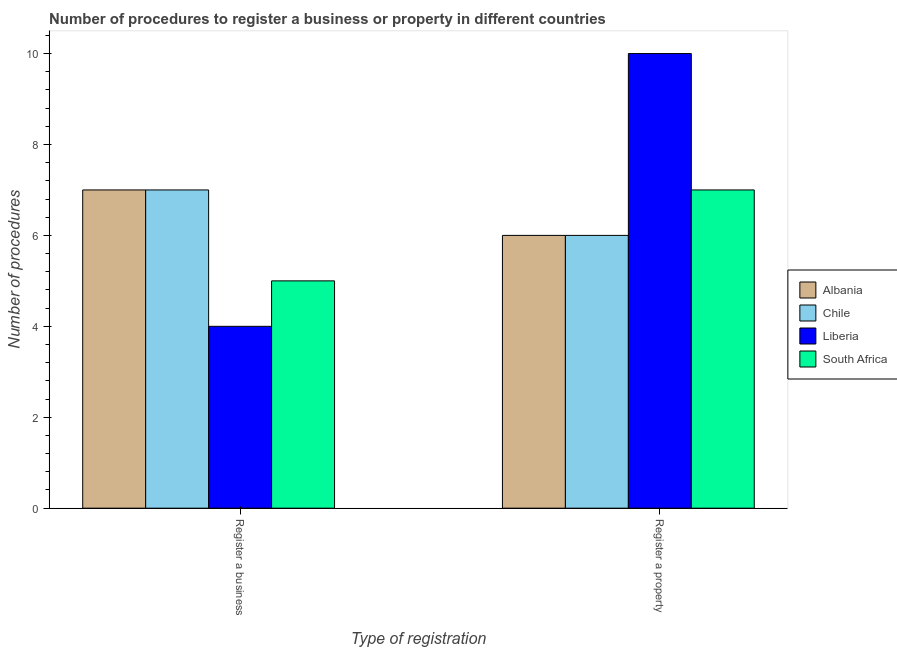How many groups of bars are there?
Provide a succinct answer. 2. How many bars are there on the 1st tick from the left?
Provide a succinct answer. 4. How many bars are there on the 2nd tick from the right?
Your answer should be compact. 4. What is the label of the 1st group of bars from the left?
Give a very brief answer. Register a business. What is the number of procedures to register a business in Chile?
Your response must be concise. 7. Across all countries, what is the maximum number of procedures to register a property?
Offer a terse response. 10. Across all countries, what is the minimum number of procedures to register a business?
Ensure brevity in your answer.  4. In which country was the number of procedures to register a property maximum?
Your answer should be compact. Liberia. In which country was the number of procedures to register a business minimum?
Give a very brief answer. Liberia. What is the total number of procedures to register a property in the graph?
Ensure brevity in your answer.  29. What is the difference between the number of procedures to register a property in Chile and that in Albania?
Ensure brevity in your answer.  0. What is the difference between the number of procedures to register a property in Liberia and the number of procedures to register a business in Chile?
Ensure brevity in your answer.  3. What is the average number of procedures to register a property per country?
Make the answer very short. 7.25. What is the difference between the number of procedures to register a business and number of procedures to register a property in South Africa?
Your answer should be very brief. -2. In how many countries, is the number of procedures to register a property greater than 8.4 ?
Your answer should be very brief. 1. What is the ratio of the number of procedures to register a property in Chile to that in South Africa?
Provide a succinct answer. 0.86. What does the 1st bar from the left in Register a property represents?
Ensure brevity in your answer.  Albania. What does the 4th bar from the right in Register a business represents?
Keep it short and to the point. Albania. How many countries are there in the graph?
Offer a terse response. 4. Are the values on the major ticks of Y-axis written in scientific E-notation?
Offer a terse response. No. Does the graph contain grids?
Your answer should be compact. No. Where does the legend appear in the graph?
Offer a very short reply. Center right. What is the title of the graph?
Provide a short and direct response. Number of procedures to register a business or property in different countries. Does "Senegal" appear as one of the legend labels in the graph?
Offer a terse response. No. What is the label or title of the X-axis?
Your response must be concise. Type of registration. What is the label or title of the Y-axis?
Provide a succinct answer. Number of procedures. What is the Number of procedures of Liberia in Register a business?
Offer a very short reply. 4. What is the Number of procedures in South Africa in Register a business?
Make the answer very short. 5. What is the Number of procedures in Chile in Register a property?
Your response must be concise. 6. What is the Number of procedures in Liberia in Register a property?
Make the answer very short. 10. Across all Type of registration, what is the maximum Number of procedures of Chile?
Offer a terse response. 7. Across all Type of registration, what is the maximum Number of procedures in South Africa?
Provide a short and direct response. 7. Across all Type of registration, what is the minimum Number of procedures of Liberia?
Offer a terse response. 4. Across all Type of registration, what is the minimum Number of procedures in South Africa?
Offer a terse response. 5. What is the total Number of procedures in Albania in the graph?
Your answer should be very brief. 13. What is the total Number of procedures in Liberia in the graph?
Keep it short and to the point. 14. What is the difference between the Number of procedures in South Africa in Register a business and that in Register a property?
Keep it short and to the point. -2. What is the difference between the Number of procedures of Albania in Register a business and the Number of procedures of Chile in Register a property?
Your answer should be compact. 1. What is the difference between the Number of procedures of Liberia in Register a business and the Number of procedures of South Africa in Register a property?
Your answer should be compact. -3. What is the difference between the Number of procedures of Albania and Number of procedures of Liberia in Register a business?
Your answer should be compact. 3. What is the difference between the Number of procedures in Albania and Number of procedures in South Africa in Register a business?
Offer a very short reply. 2. What is the difference between the Number of procedures of Chile and Number of procedures of Liberia in Register a business?
Provide a succinct answer. 3. What is the difference between the Number of procedures in Liberia and Number of procedures in South Africa in Register a business?
Provide a succinct answer. -1. What is the difference between the Number of procedures of Albania and Number of procedures of South Africa in Register a property?
Make the answer very short. -1. What is the difference between the Number of procedures of Liberia and Number of procedures of South Africa in Register a property?
Keep it short and to the point. 3. What is the ratio of the Number of procedures of Chile in Register a business to that in Register a property?
Your answer should be very brief. 1.17. What is the difference between the highest and the second highest Number of procedures in Liberia?
Make the answer very short. 6. What is the difference between the highest and the lowest Number of procedures in Albania?
Ensure brevity in your answer.  1. What is the difference between the highest and the lowest Number of procedures of Chile?
Your answer should be very brief. 1. 